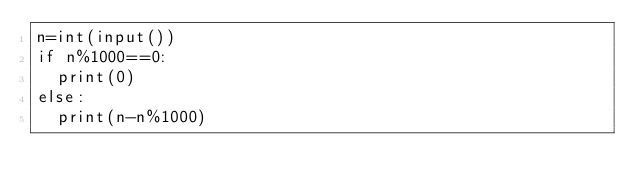Convert code to text. <code><loc_0><loc_0><loc_500><loc_500><_Python_>n=int(input())
if n%1000==0:
  print(0)
else:
  print(n-n%1000)</code> 